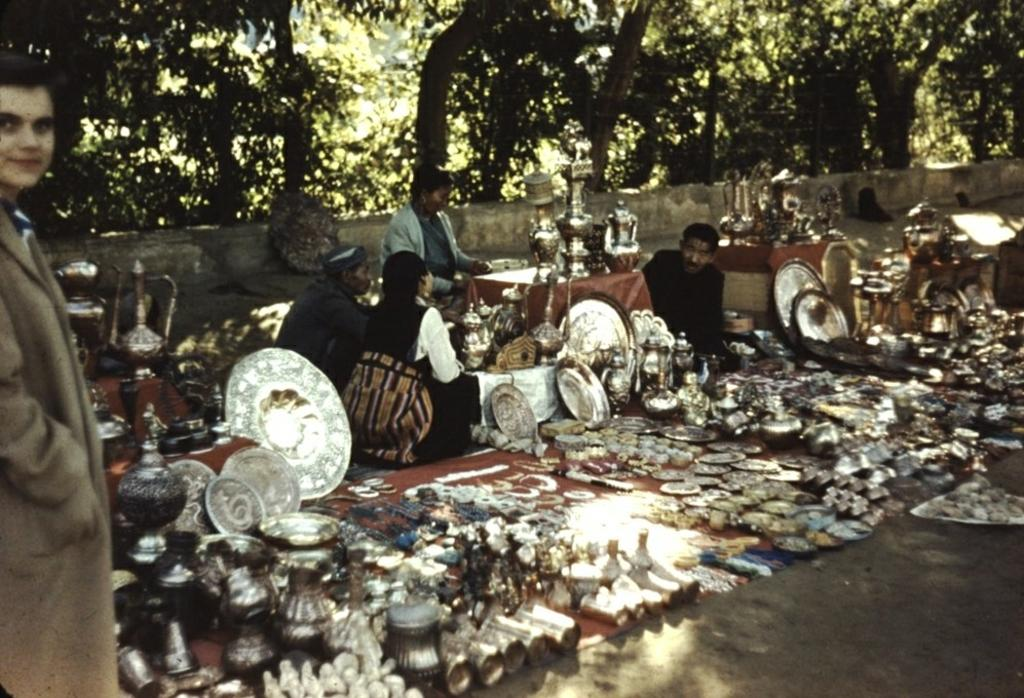What is located on the road in the image? There are vessels and objects on the road in the image. What are the people near the vessels doing? The people sitting near the vessels are likely resting or taking a break. What can be seen in the background of the image? There are trees visible in the background of the image. Where is the person standing in the image? The person standing is on the left side of the image. Is there a volleyball game happening on the road in the image? No, there is no volleyball game present in the image. What type of border is visible in the image? There is no border visible in the image; it features a road, vessels, objects, and people. 